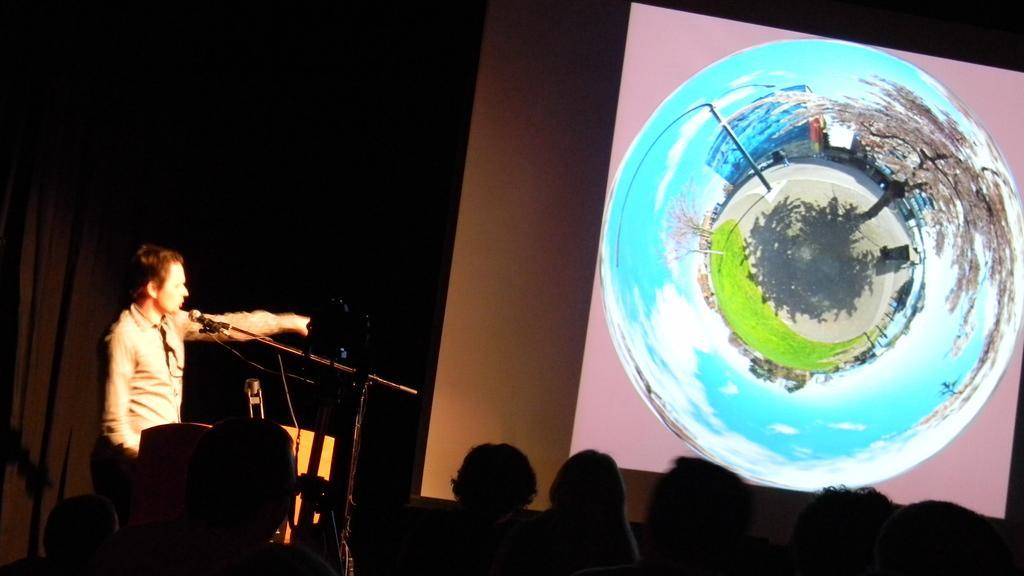How would you summarize this image in a sentence or two? This picture is clicked inside. In the foreground we can see the group of persons. On the left there is a person standing and we can see a microphone attached to the metal stand. In the background we can see the curtain and a wall and we can see the picture of some objects on the projector screen. 